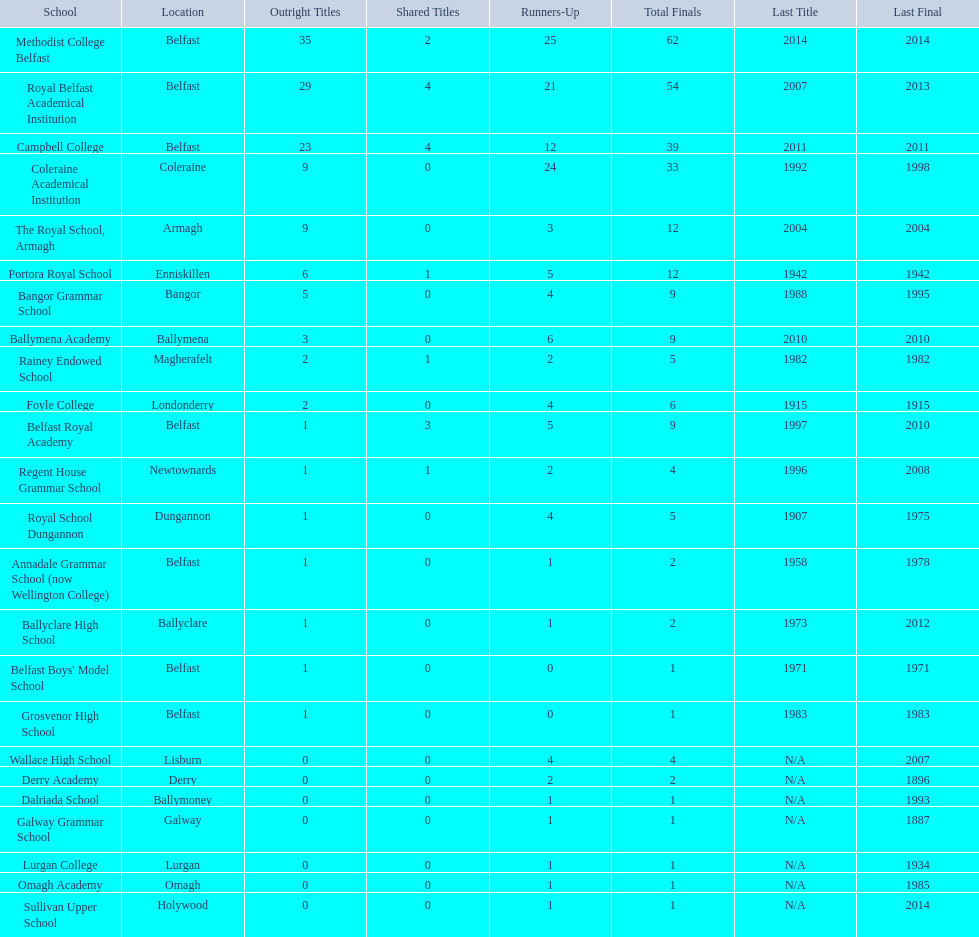Who holds the latest title victory, campbell college or regent house grammar school? Campbell College. 